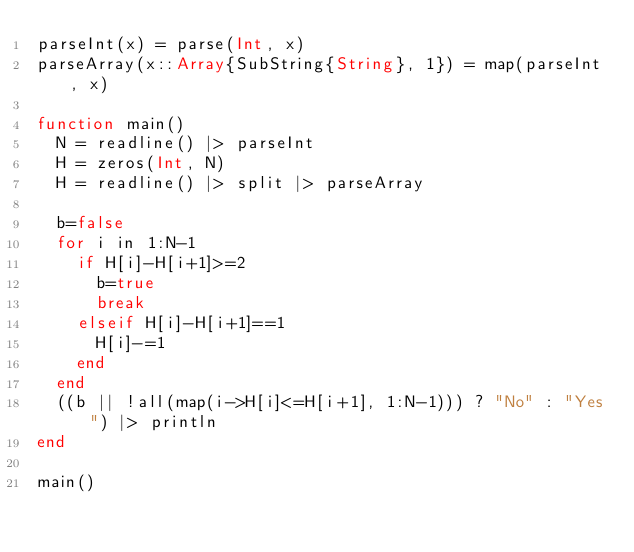<code> <loc_0><loc_0><loc_500><loc_500><_Julia_>parseInt(x) = parse(Int, x)
parseArray(x::Array{SubString{String}, 1}) = map(parseInt, x)

function main()
  N = readline() |> parseInt
  H = zeros(Int, N)
  H = readline() |> split |> parseArray

  b=false
  for i in 1:N-1
    if H[i]-H[i+1]>=2
      b=true
      break
    elseif H[i]-H[i+1]==1
      H[i]-=1
    end
  end
  ((b || !all(map(i->H[i]<=H[i+1], 1:N-1))) ? "No" : "Yes") |> println
end

main()
</code> 